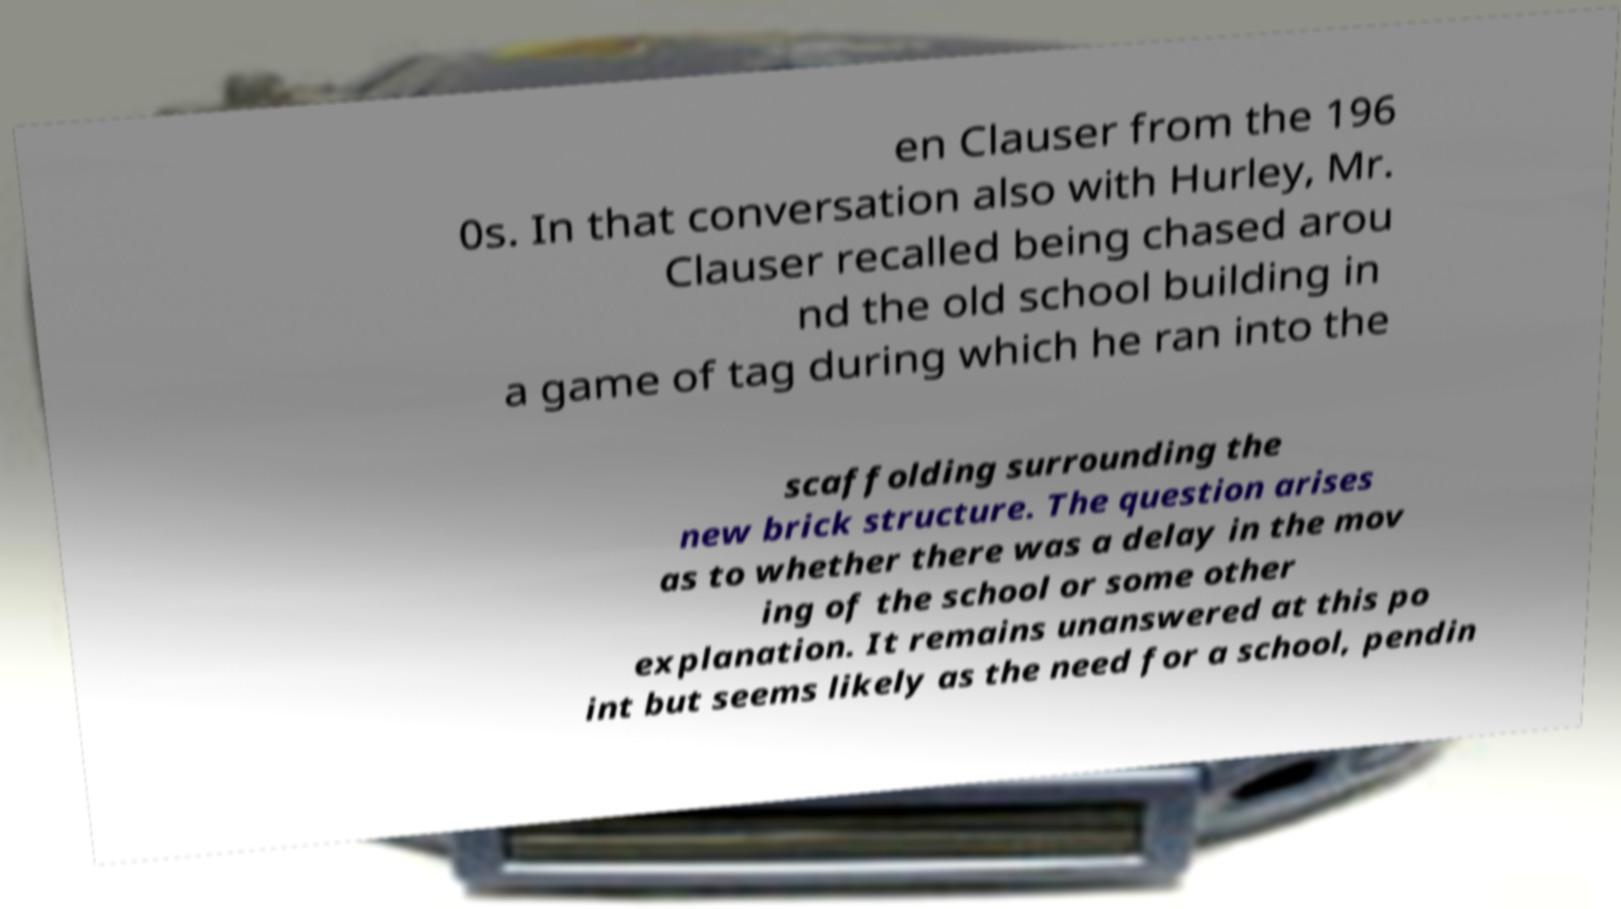Can you read and provide the text displayed in the image?This photo seems to have some interesting text. Can you extract and type it out for me? en Clauser from the 196 0s. In that conversation also with Hurley, Mr. Clauser recalled being chased arou nd the old school building in a game of tag during which he ran into the scaffolding surrounding the new brick structure. The question arises as to whether there was a delay in the mov ing of the school or some other explanation. It remains unanswered at this po int but seems likely as the need for a school, pendin 